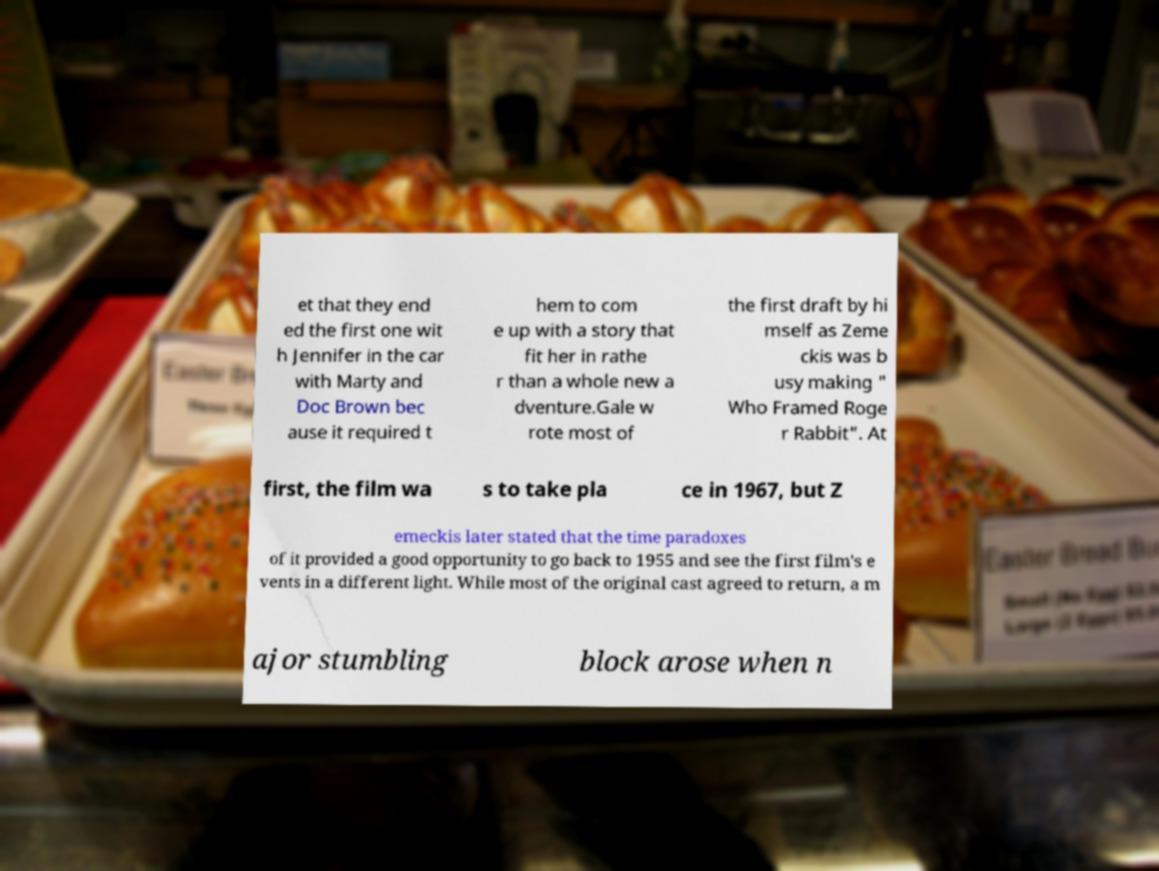I need the written content from this picture converted into text. Can you do that? et that they end ed the first one wit h Jennifer in the car with Marty and Doc Brown bec ause it required t hem to com e up with a story that fit her in rathe r than a whole new a dventure.Gale w rote most of the first draft by hi mself as Zeme ckis was b usy making " Who Framed Roge r Rabbit". At first, the film wa s to take pla ce in 1967, but Z emeckis later stated that the time paradoxes of it provided a good opportunity to go back to 1955 and see the first film's e vents in a different light. While most of the original cast agreed to return, a m ajor stumbling block arose when n 